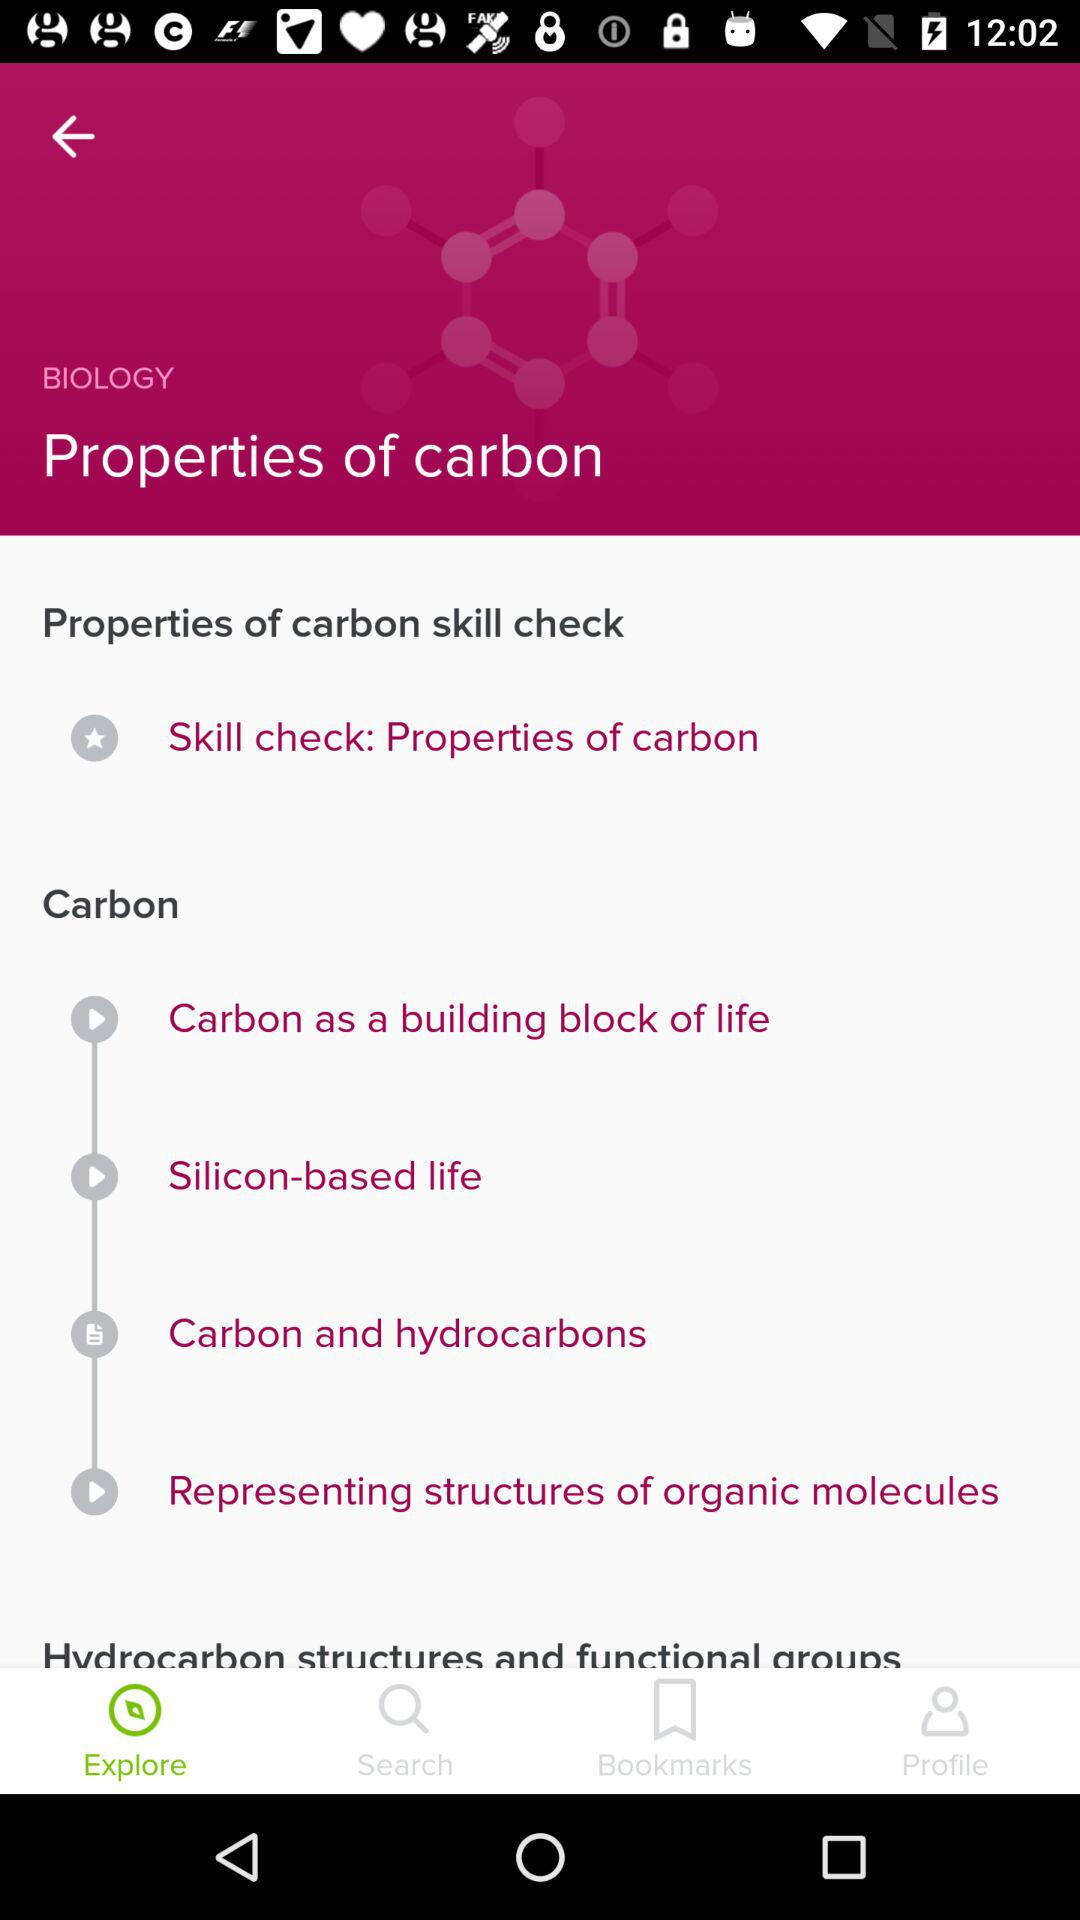What are the sections of "Hydrocarbon structures and functional groups"?
When the provided information is insufficient, respond with <no answer>. <no answer> 